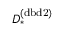<formula> <loc_0><loc_0><loc_500><loc_500>D _ { * } ^ { ( d b d 2 ) }</formula> 